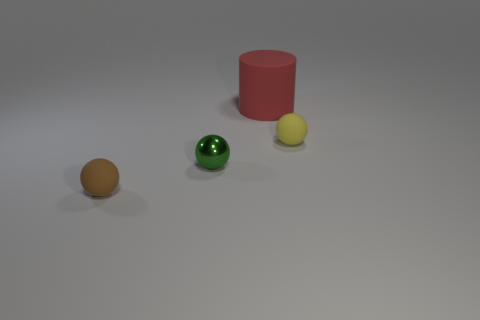Is there anything else that is the same shape as the red matte object?
Provide a succinct answer. No. What material is the brown object?
Your answer should be compact. Rubber. What number of other objects are there of the same size as the green shiny thing?
Keep it short and to the point. 2. There is a rubber sphere that is to the right of the tiny green metallic thing; what is its size?
Your answer should be compact. Small. There is a tiny green sphere right of the matte sphere that is left of the small matte object to the right of the small brown ball; what is it made of?
Keep it short and to the point. Metal. Do the small yellow matte thing and the tiny green object have the same shape?
Keep it short and to the point. Yes. How many shiny things are either tiny brown spheres or big blue balls?
Give a very brief answer. 0. What number of tiny purple cylinders are there?
Ensure brevity in your answer.  0. There is a metallic thing that is the same size as the yellow rubber ball; what is its color?
Your response must be concise. Green. Is the size of the yellow matte thing the same as the red cylinder?
Provide a short and direct response. No. 